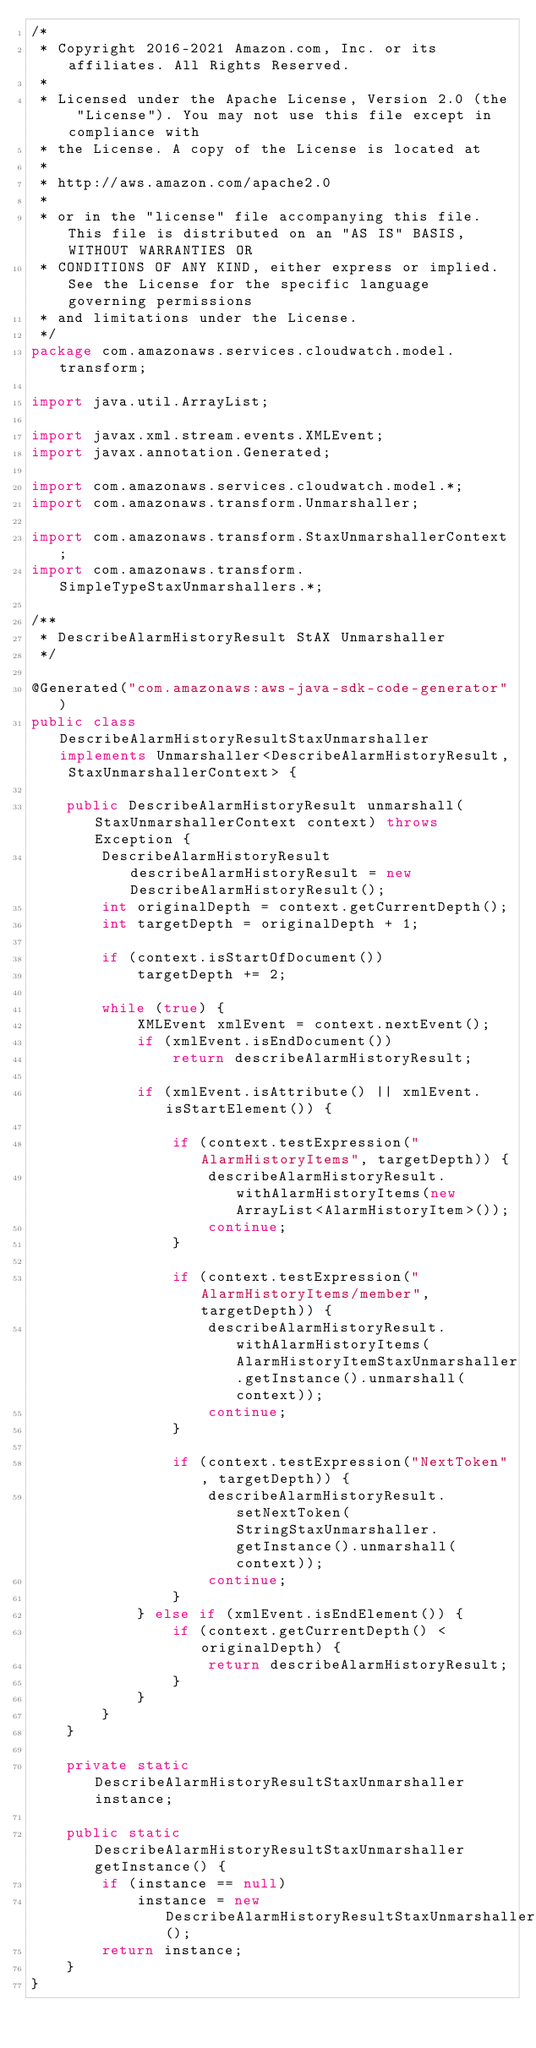<code> <loc_0><loc_0><loc_500><loc_500><_Java_>/*
 * Copyright 2016-2021 Amazon.com, Inc. or its affiliates. All Rights Reserved.
 * 
 * Licensed under the Apache License, Version 2.0 (the "License"). You may not use this file except in compliance with
 * the License. A copy of the License is located at
 * 
 * http://aws.amazon.com/apache2.0
 * 
 * or in the "license" file accompanying this file. This file is distributed on an "AS IS" BASIS, WITHOUT WARRANTIES OR
 * CONDITIONS OF ANY KIND, either express or implied. See the License for the specific language governing permissions
 * and limitations under the License.
 */
package com.amazonaws.services.cloudwatch.model.transform;

import java.util.ArrayList;

import javax.xml.stream.events.XMLEvent;
import javax.annotation.Generated;

import com.amazonaws.services.cloudwatch.model.*;
import com.amazonaws.transform.Unmarshaller;

import com.amazonaws.transform.StaxUnmarshallerContext;
import com.amazonaws.transform.SimpleTypeStaxUnmarshallers.*;

/**
 * DescribeAlarmHistoryResult StAX Unmarshaller
 */

@Generated("com.amazonaws:aws-java-sdk-code-generator")
public class DescribeAlarmHistoryResultStaxUnmarshaller implements Unmarshaller<DescribeAlarmHistoryResult, StaxUnmarshallerContext> {

    public DescribeAlarmHistoryResult unmarshall(StaxUnmarshallerContext context) throws Exception {
        DescribeAlarmHistoryResult describeAlarmHistoryResult = new DescribeAlarmHistoryResult();
        int originalDepth = context.getCurrentDepth();
        int targetDepth = originalDepth + 1;

        if (context.isStartOfDocument())
            targetDepth += 2;

        while (true) {
            XMLEvent xmlEvent = context.nextEvent();
            if (xmlEvent.isEndDocument())
                return describeAlarmHistoryResult;

            if (xmlEvent.isAttribute() || xmlEvent.isStartElement()) {

                if (context.testExpression("AlarmHistoryItems", targetDepth)) {
                    describeAlarmHistoryResult.withAlarmHistoryItems(new ArrayList<AlarmHistoryItem>());
                    continue;
                }

                if (context.testExpression("AlarmHistoryItems/member", targetDepth)) {
                    describeAlarmHistoryResult.withAlarmHistoryItems(AlarmHistoryItemStaxUnmarshaller.getInstance().unmarshall(context));
                    continue;
                }

                if (context.testExpression("NextToken", targetDepth)) {
                    describeAlarmHistoryResult.setNextToken(StringStaxUnmarshaller.getInstance().unmarshall(context));
                    continue;
                }
            } else if (xmlEvent.isEndElement()) {
                if (context.getCurrentDepth() < originalDepth) {
                    return describeAlarmHistoryResult;
                }
            }
        }
    }

    private static DescribeAlarmHistoryResultStaxUnmarshaller instance;

    public static DescribeAlarmHistoryResultStaxUnmarshaller getInstance() {
        if (instance == null)
            instance = new DescribeAlarmHistoryResultStaxUnmarshaller();
        return instance;
    }
}
</code> 